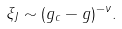<formula> <loc_0><loc_0><loc_500><loc_500>\xi _ { J } \sim ( g _ { c } - g ) ^ { - \nu } .</formula> 